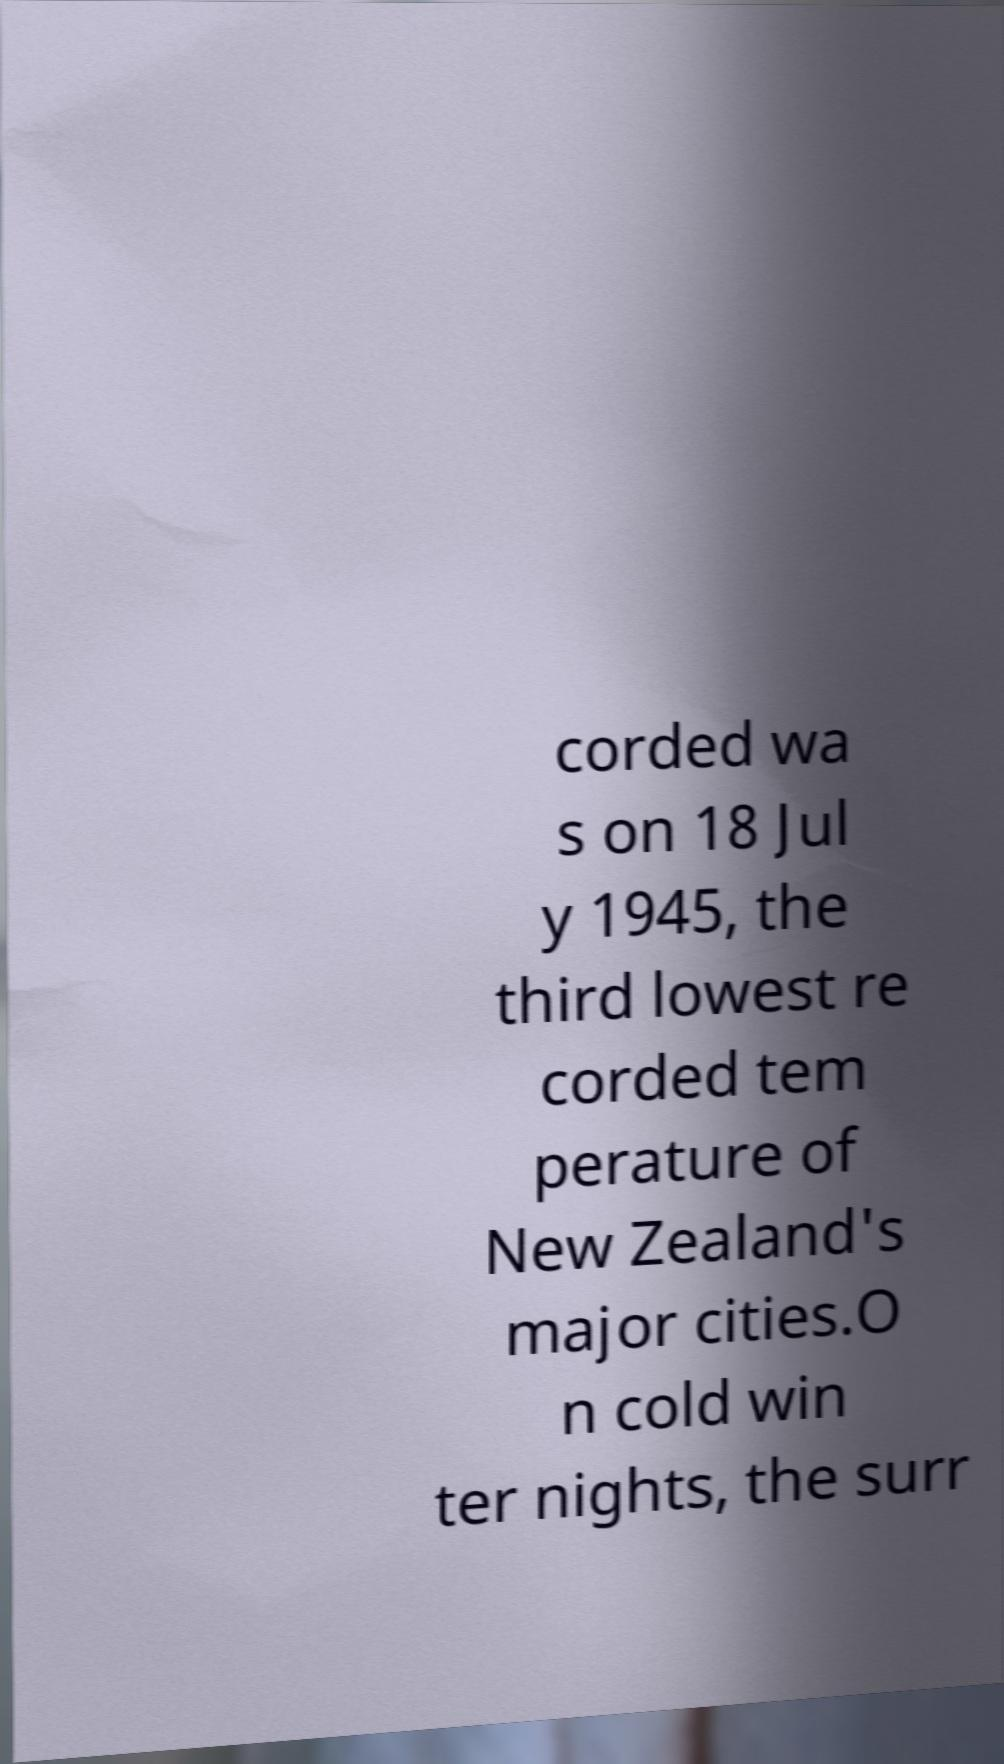I need the written content from this picture converted into text. Can you do that? corded wa s on 18 Jul y 1945, the third lowest re corded tem perature of New Zealand's major cities.O n cold win ter nights, the surr 